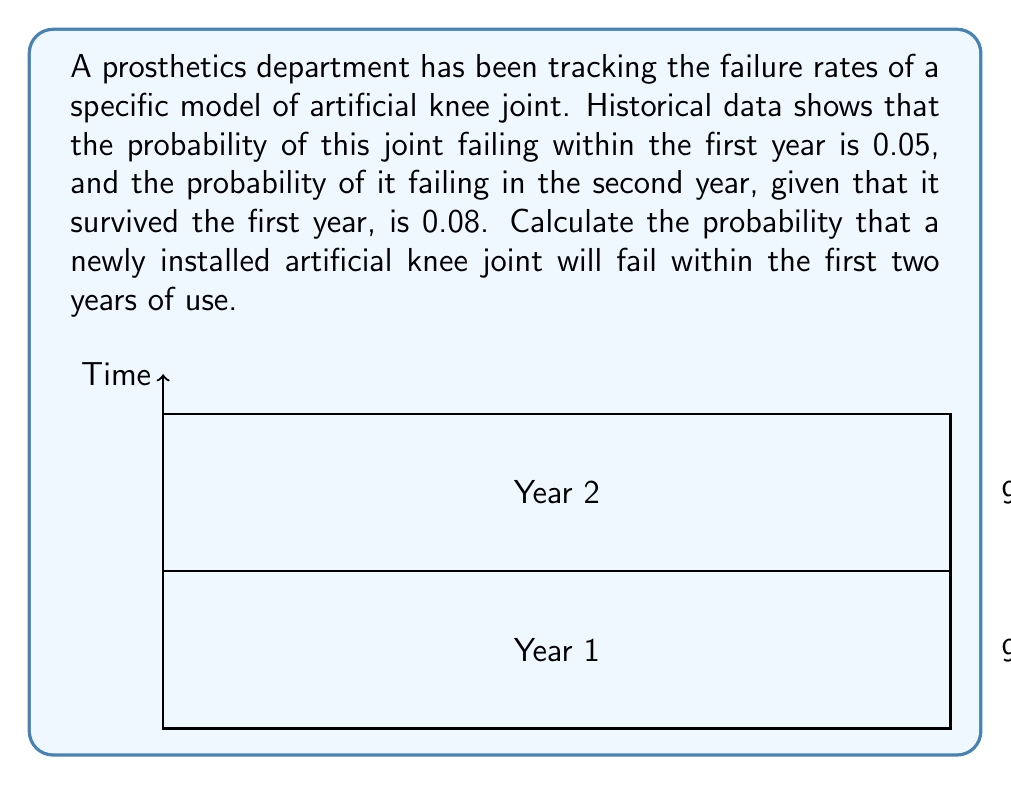Teach me how to tackle this problem. To solve this problem, we need to use the concept of conditional probability and the complement of probability.

Step 1: Define the events
Let $F_1$ be the event of failure in the first year
Let $F_2$ be the event of failure in the second year
Let $S_1$ be the event of surviving the first year

Step 2: Given probabilities
$P(F_1) = 0.05$
$P(F_2|S_1) = 0.08$

Step 3: Calculate the probability of surviving the first year
$P(S_1) = 1 - P(F_1) = 1 - 0.05 = 0.95$

Step 4: Calculate the probability of failing in the second year
$P(F_2 \cap S_1) = P(F_2|S_1) \cdot P(S_1) = 0.08 \cdot 0.95 = 0.076$

Step 5: Calculate the total probability of failing within two years
The joint can fail either in the first year or in the second year. These are mutually exclusive events, so we add their probabilities:

$P(\text{Fail within 2 years}) = P(F_1) + P(F_2 \cap S_1) = 0.05 + 0.076 = 0.126$

Therefore, the probability that a newly installed artificial knee joint will fail within the first two years of use is 0.126 or 12.6%.
Answer: $0.126$ or $12.6\%$ 